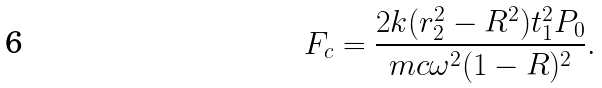Convert formula to latex. <formula><loc_0><loc_0><loc_500><loc_500>F _ { c } = \frac { 2 k ( r _ { 2 } ^ { 2 } - R ^ { 2 } ) t _ { 1 } ^ { 2 } P _ { 0 } } { m c \omega ^ { 2 } ( 1 - R ) ^ { 2 } } .</formula> 